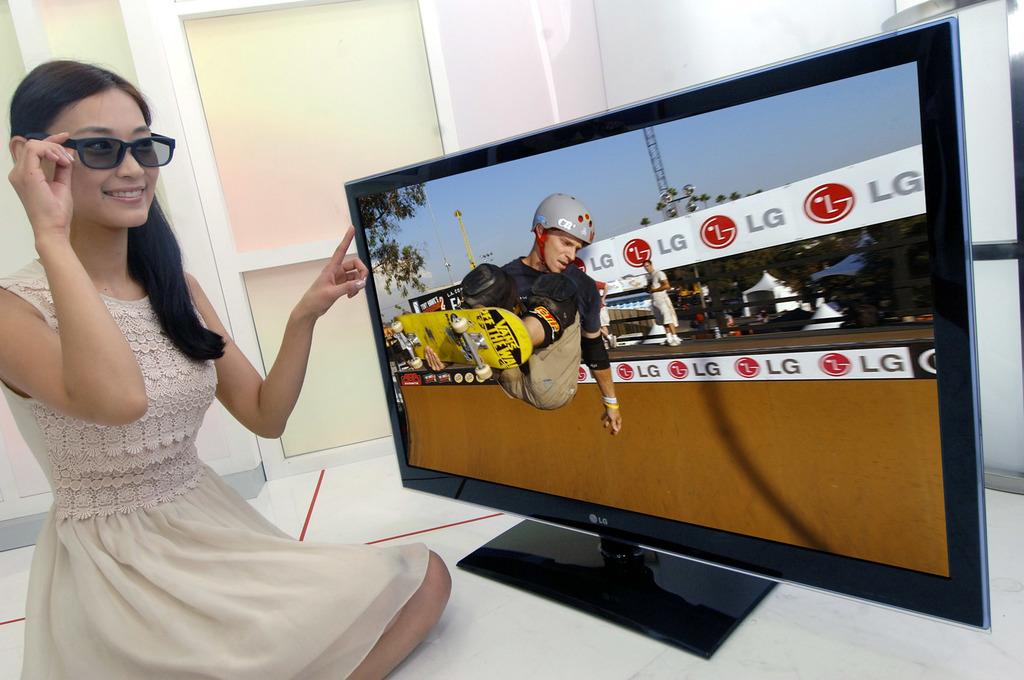Which company is sponsoring the event on tv?
Make the answer very short. Lg. What is written on the bottom of the skateboard?
Provide a short and direct response. Vans off the wall. 